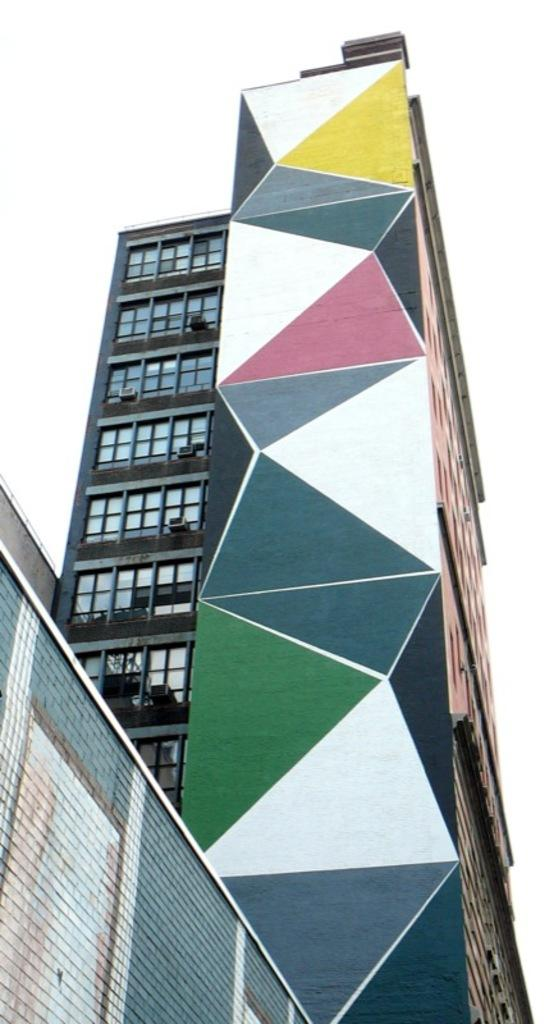Where was the picture taken? The picture was clicked outside. What can be seen in the image besides the outdoor setting? There are buildings visible in the image. Can you describe the appearance of one of the buildings? There is a colorful wall of a building visible in the image. What is visible in the background of the image? The sky is visible in the background of the image. What else can be seen in the background of the image? There are other objects present in the background of the image. How many hands are visible in the image? There are no hands visible in the image. What type of zebra can be seen in the image? There is no zebra present in the image. 